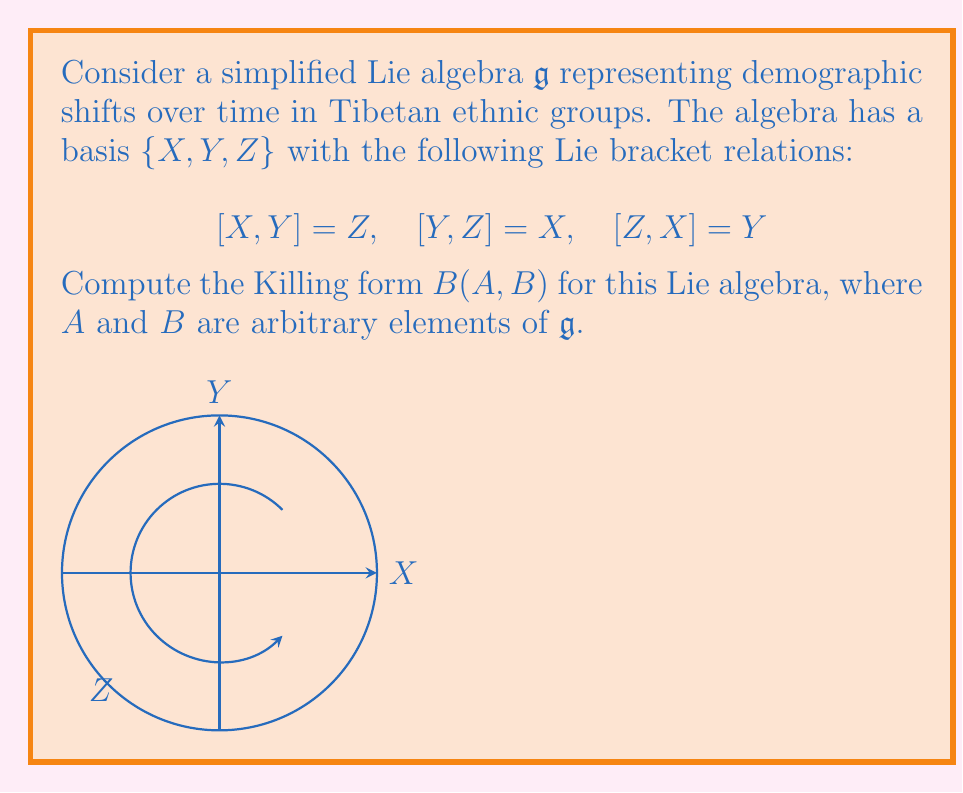Solve this math problem. To compute the Killing form for this Lie algebra, we follow these steps:

1) The Killing form is defined as $B(A,B) = \text{tr}(\text{ad}(A) \circ \text{ad}(B))$, where $\text{ad}$ is the adjoint representation.

2) First, we need to find the matrix representations of $\text{ad}(X)$, $\text{ad}(Y)$, and $\text{ad}(Z)$:

   $\text{ad}(X) = \begin{pmatrix} 0 & 0 & -1 \\ 0 & 0 & 0 \\ 0 & 1 & 0 \end{pmatrix}$

   $\text{ad}(Y) = \begin{pmatrix} 0 & 0 & 0 \\ 0 & 0 & -1 \\ -1 & 0 & 0 \end{pmatrix}$

   $\text{ad}(Z) = \begin{pmatrix} 0 & -1 & 0 \\ 1 & 0 & 0 \\ 0 & 0 & 0 \end{pmatrix}$

3) Now, let $A = aX + bY + cZ$ and $B = dX + eY + fZ$ be arbitrary elements of $\mathfrak{g}$.

4) We compute $\text{ad}(A) = a\text{ad}(X) + b\text{ad}(Y) + c\text{ad}(Z)$:

   $\text{ad}(A) = \begin{pmatrix} 0 & -c & -b \\ c & 0 & -a \\ -b & a & 0 \end{pmatrix}$

5) Similarly, $\text{ad}(B) = d\text{ad}(X) + e\text{ad}(Y) + f\text{ad}(Z)$:

   $\text{ad}(B) = \begin{pmatrix} 0 & -f & -e \\ f & 0 & -d \\ -e & d & 0 \end{pmatrix}$

6) We multiply these matrices:

   $\text{ad}(A) \circ \text{ad}(B) = \begin{pmatrix} -be-cf & -af & -ae \\ -bf & -ae-cf & -bd \\ -cd & -ce & -be-af \end{pmatrix}$

7) The trace of this matrix is:

   $\text{tr}(\text{ad}(A) \circ \text{ad}(B)) = -2(ae+bf+cd)$

8) Therefore, the Killing form is:

   $B(A,B) = -2(ae+bf+cd)$
Answer: $B(A,B) = -2(ae+bf+cd)$ 